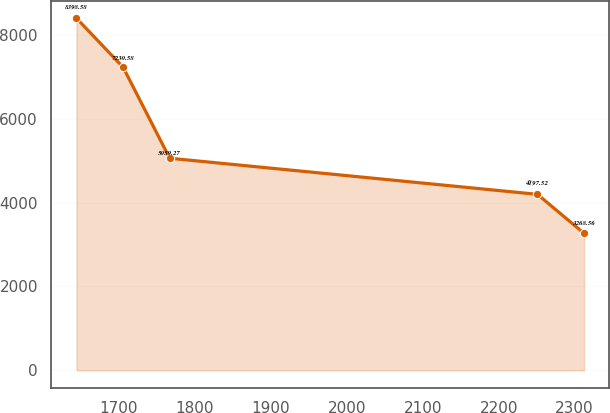Convert chart. <chart><loc_0><loc_0><loc_500><loc_500><line_chart><ecel><fcel>Unnamed: 1<nl><fcel>1644.04<fcel>8398.58<nl><fcel>1705.39<fcel>7230.58<nl><fcel>1766.74<fcel>5059.27<nl><fcel>2251.02<fcel>4197.52<nl><fcel>2312.37<fcel>3268.56<nl></chart> 